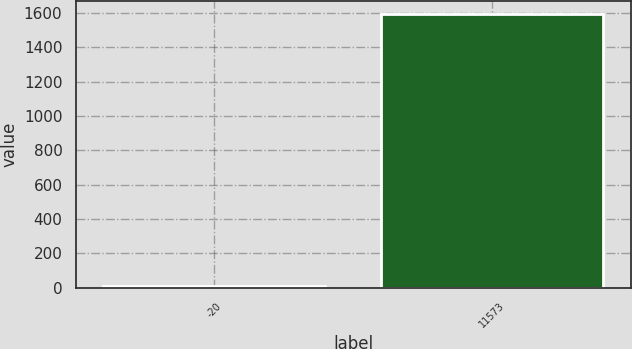<chart> <loc_0><loc_0><loc_500><loc_500><bar_chart><fcel>-20<fcel>11573<nl><fcel>10<fcel>1591.3<nl></chart> 